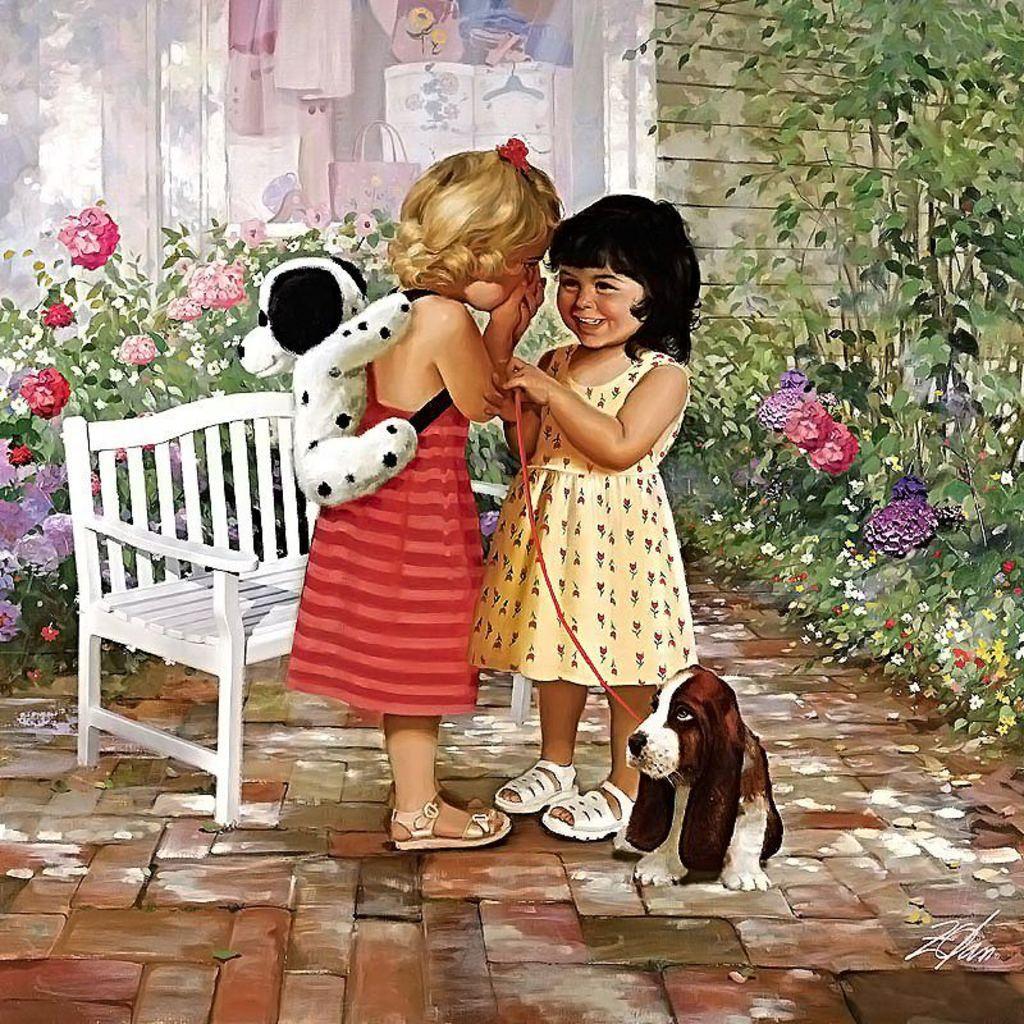Can you describe this image briefly? In this picture there is a girl wearing a bag and there is another girl was smiling, she is holding a puppy and the bench they are flowers and trees and there is a wall behind them 